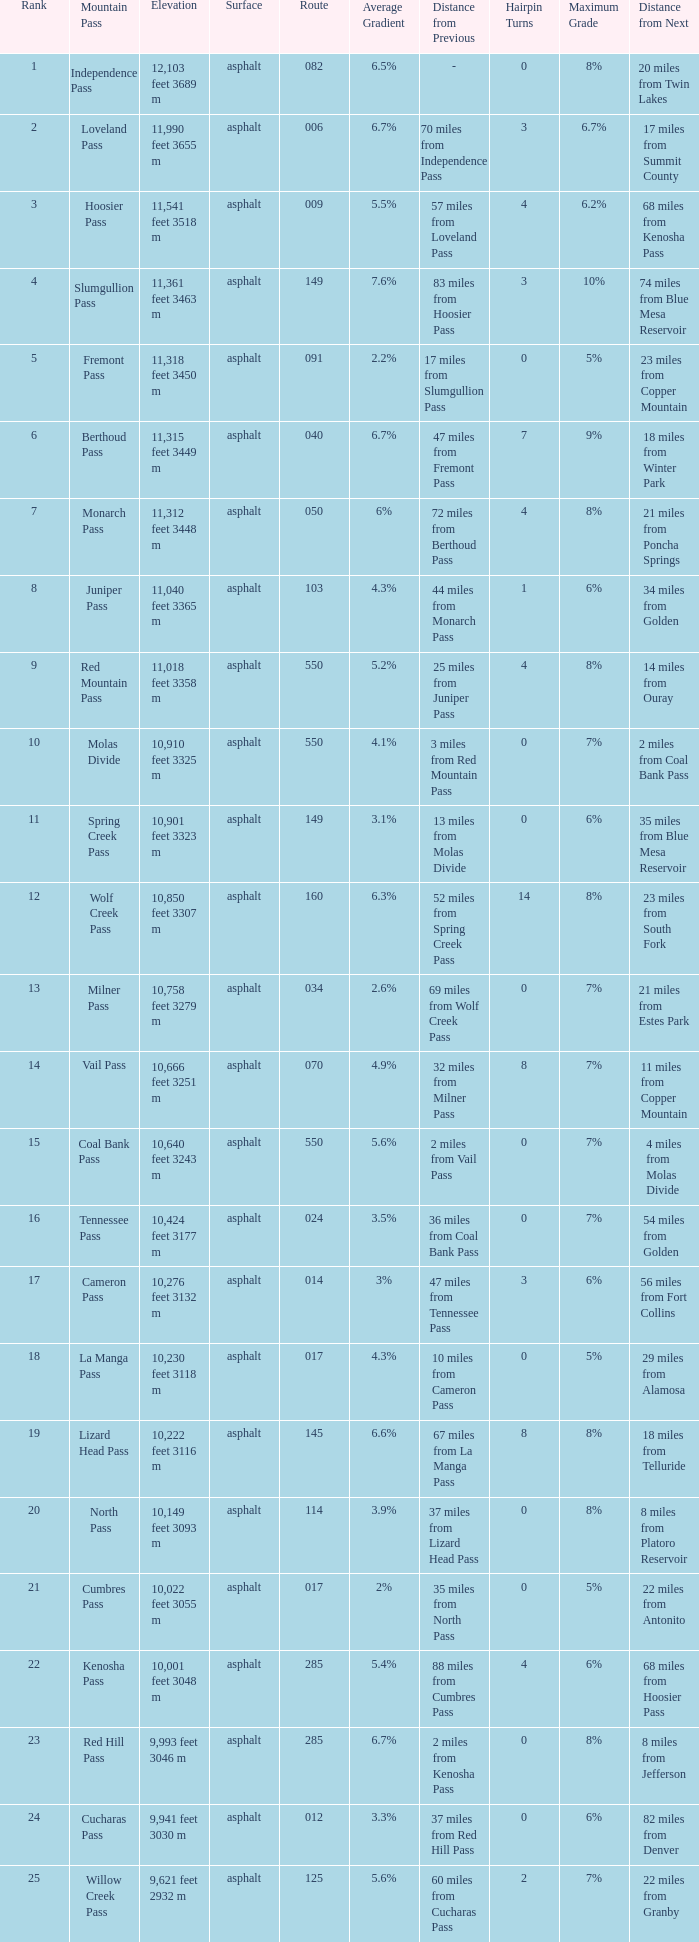On what Route is the mountain with a Rank less than 33 and an Elevation of 11,312 feet 3448 m? 50.0. 